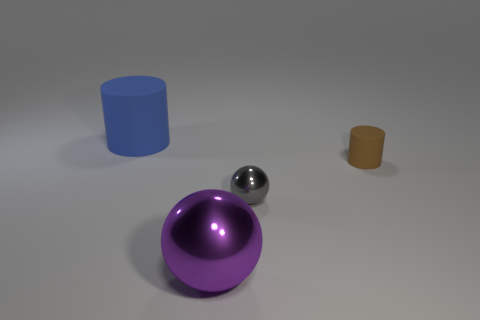Add 2 tiny gray balls. How many objects exist? 6 Subtract 0 blue balls. How many objects are left? 4 Subtract all blue objects. Subtract all gray spheres. How many objects are left? 2 Add 4 purple objects. How many purple objects are left? 5 Add 3 tiny brown matte cylinders. How many tiny brown matte cylinders exist? 4 